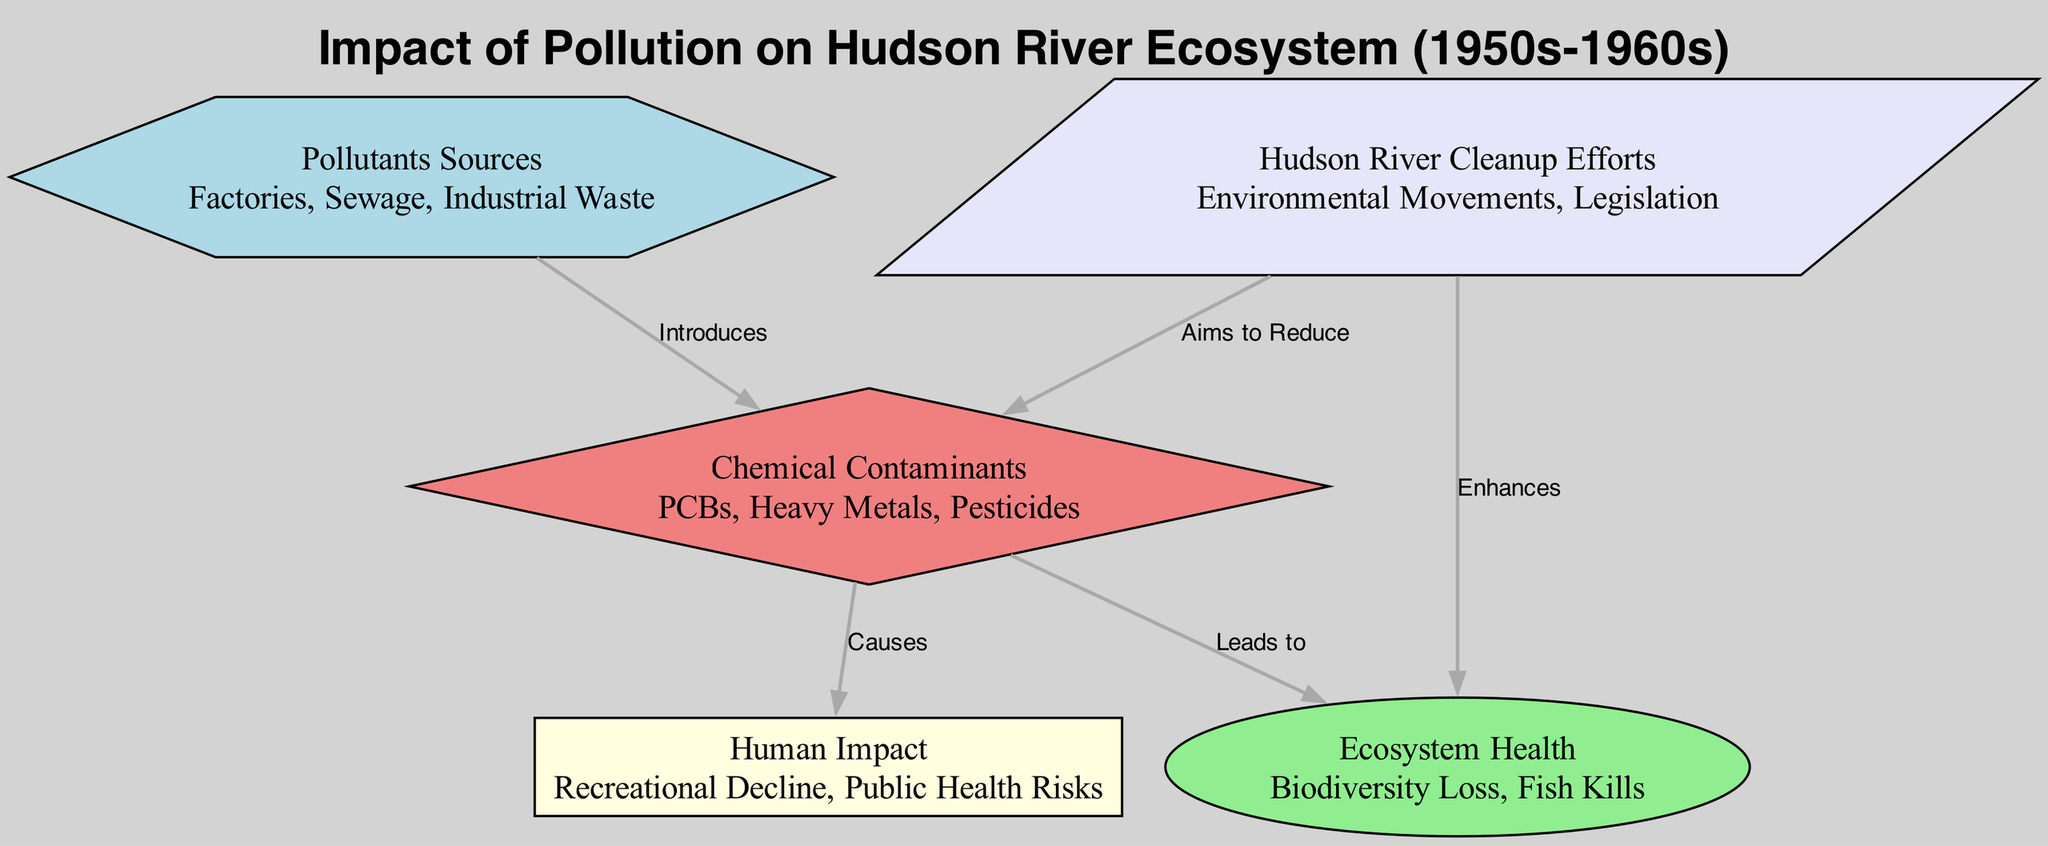What are the main sources of pollutants? The diagram lists "Factories, Sewage, Industrial Waste" as the primary sources of pollutants. These sources are represented as a node labeled "Pollutants Sources".
Answer: Factories, Sewage, Industrial Waste How many types of chemical contaminants are listed? There is one node labeled "Chemical Contaminants" which details three types: "PCBs, Heavy Metals, Pesticides". Hence, there are three distinct types mentioned.
Answer: 3 What does chemical contamination lead to? The edge directly connecting "Chemical Contaminants" to "Ecosystem Health" is labeled "Leads to", indicating that chemical contamination causes harm to ecosystem health.
Answer: Ecosystem Health Which node aims to reduce chemical contaminants? The edge connecting "Hudson River Cleanup Efforts" to "Chemical Contaminants" is labeled "Aims to Reduce", showing that the cleanup efforts focus on reducing the levels of chemical contaminants.
Answer: Hudson River Cleanup Efforts How do pollutants impact human health according to the diagram? The diagram indicates that chemical contaminants "Causes" human impacts, which include "Recreational Decline" and "Public Health Risks", showing a direct link from pollutants to human health concerns.
Answer: Public Health Risks What effect do cleanup efforts have on ecosystem health? The diagram illustrates that "Hudson River Cleanup Efforts" has an edge pointing to "Ecosystem Health" labeled "Enhances", suggesting that cleanup efforts positively influence the overall health of the ecosystem.
Answer: Enhances What is the relationship between pollutants sources and human impact? Pollutants originate from sources like "Factories, Sewage, Industrial Waste" and then cause negative effects on human activities such as recreational decline and public health risks, indicated by the edges. This reflects the impact flow from pollutants to human life.
Answer: Causes How many edges are there in total in the diagram? The diagram contains five edges connecting the various nodes, representing the relationships between pollutants, their sources, and their effects.
Answer: 5 